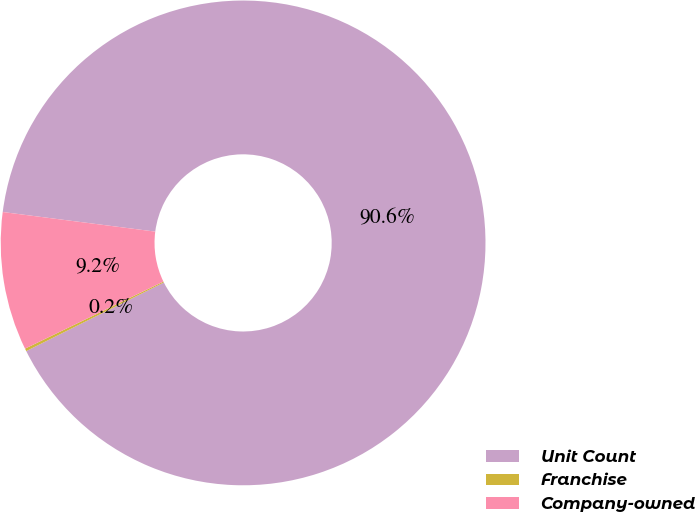Convert chart. <chart><loc_0><loc_0><loc_500><loc_500><pie_chart><fcel>Unit Count<fcel>Franchise<fcel>Company-owned<nl><fcel>90.6%<fcel>0.18%<fcel>9.22%<nl></chart> 